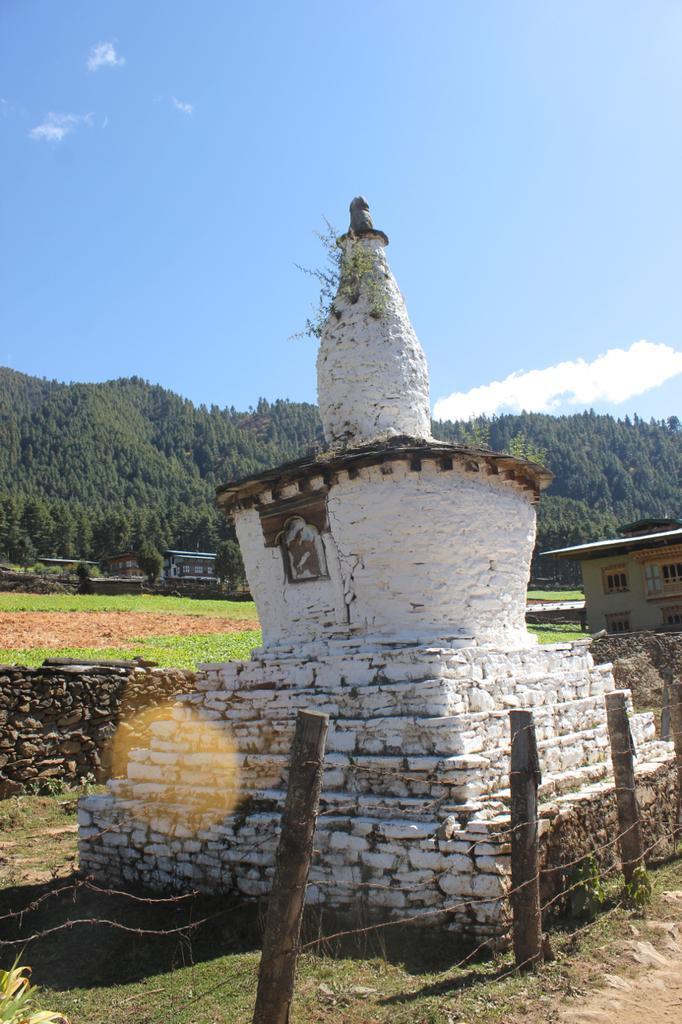In one or two sentences, can you explain what this image depicts? In this image I can see few wooden poles and wires. In the background I can see white colour thing, few buildings, grass, number of trees, clouds and the sky. 